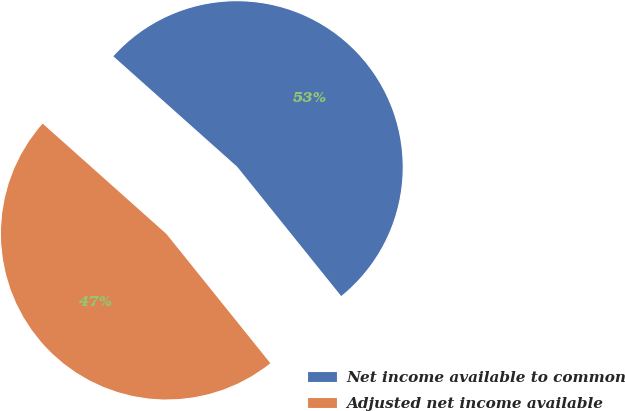<chart> <loc_0><loc_0><loc_500><loc_500><pie_chart><fcel>Net income available to common<fcel>Adjusted net income available<nl><fcel>52.63%<fcel>47.37%<nl></chart> 